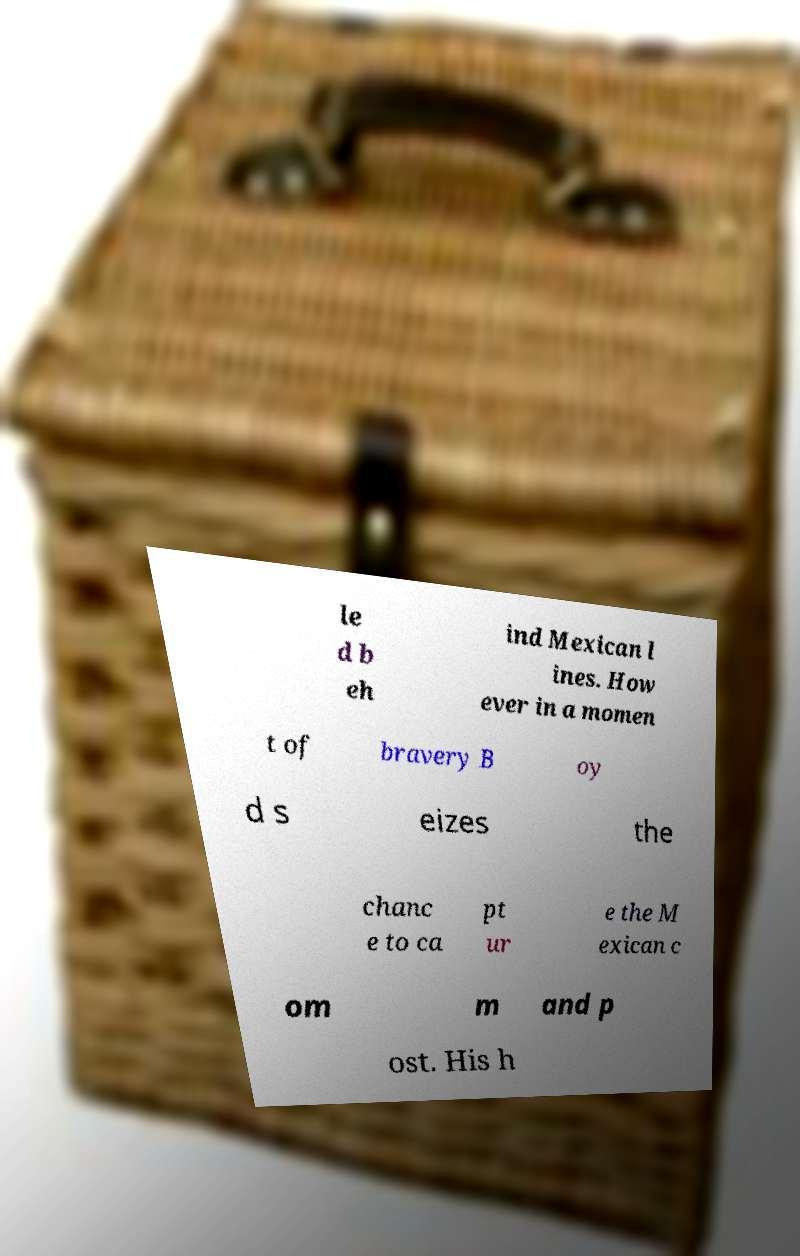What messages or text are displayed in this image? I need them in a readable, typed format. le d b eh ind Mexican l ines. How ever in a momen t of bravery B oy d s eizes the chanc e to ca pt ur e the M exican c om m and p ost. His h 